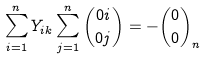Convert formula to latex. <formula><loc_0><loc_0><loc_500><loc_500>\sum _ { i = 1 } ^ { n } Y _ { i k } \sum _ { j = 1 } ^ { n } { \binom { 0 i } { 0 j } } = - { \binom { 0 } { 0 } } _ { n }</formula> 